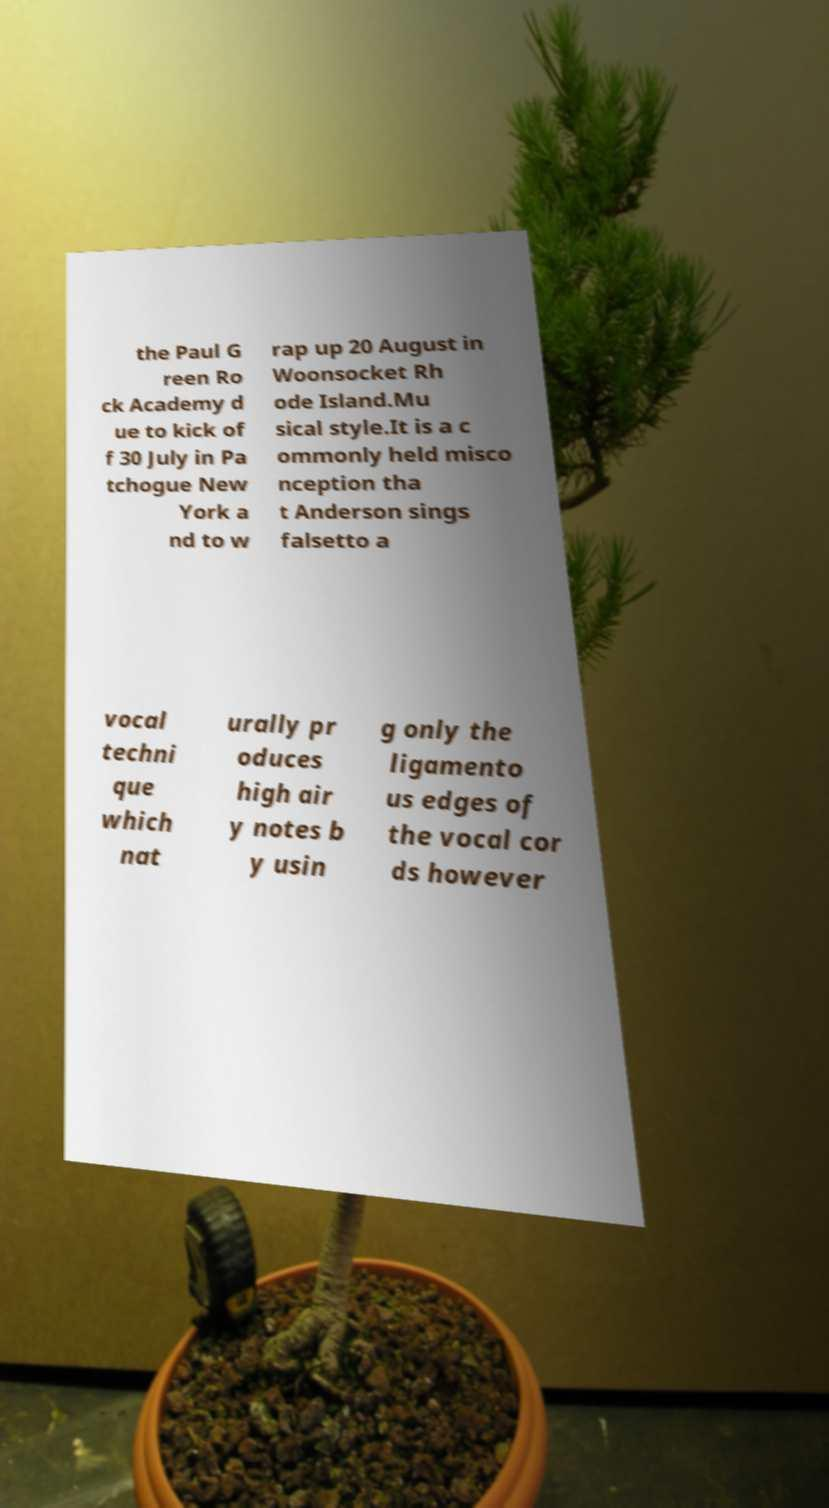Can you accurately transcribe the text from the provided image for me? the Paul G reen Ro ck Academy d ue to kick of f 30 July in Pa tchogue New York a nd to w rap up 20 August in Woonsocket Rh ode Island.Mu sical style.It is a c ommonly held misco nception tha t Anderson sings falsetto a vocal techni que which nat urally pr oduces high air y notes b y usin g only the ligamento us edges of the vocal cor ds however 